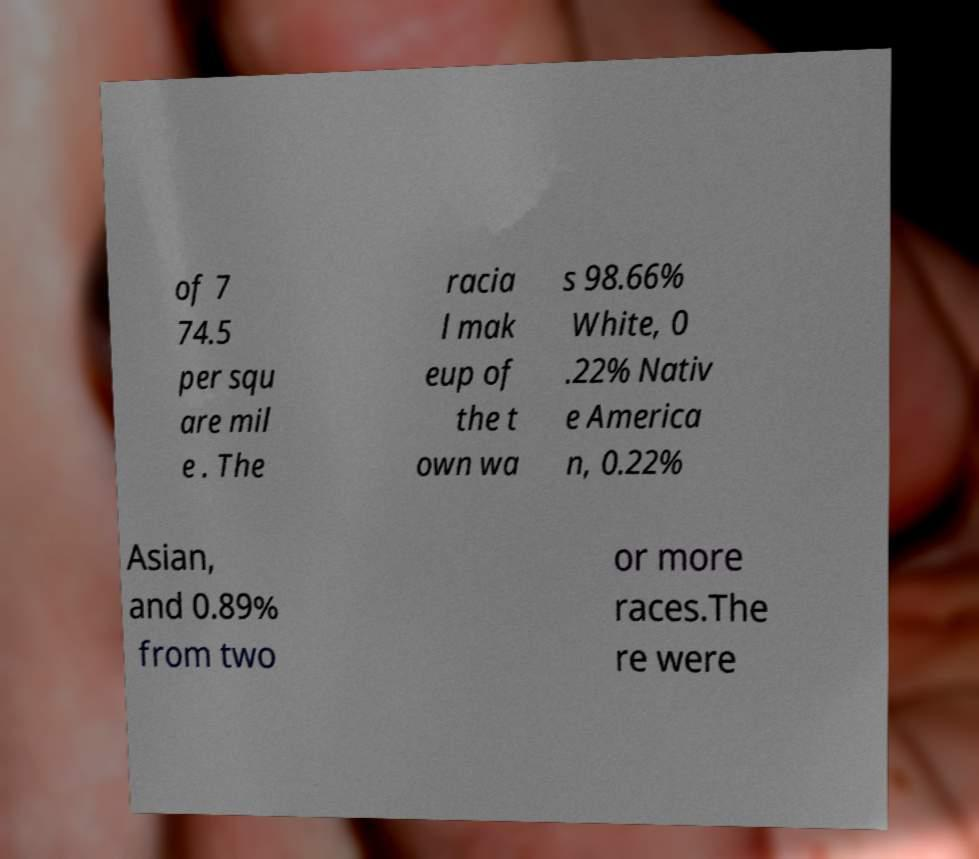Please read and relay the text visible in this image. What does it say? of 7 74.5 per squ are mil e . The racia l mak eup of the t own wa s 98.66% White, 0 .22% Nativ e America n, 0.22% Asian, and 0.89% from two or more races.The re were 